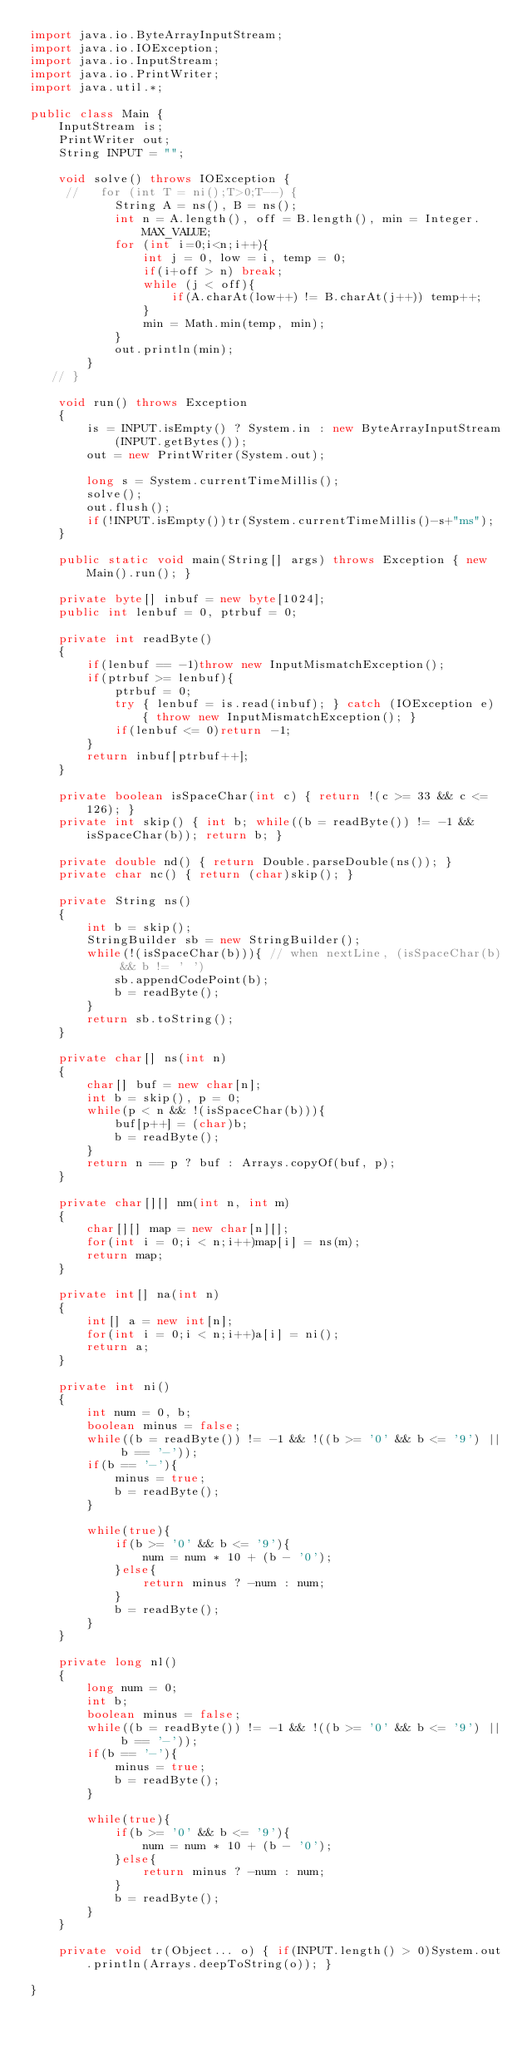Convert code to text. <code><loc_0><loc_0><loc_500><loc_500><_Java_>import java.io.ByteArrayInputStream;
import java.io.IOException;
import java.io.InputStream;
import java.io.PrintWriter;
import java.util.*;

public class Main {
    InputStream is;
    PrintWriter out;
    String INPUT = "";

    void solve() throws IOException {
     //   for (int T = ni();T>0;T--) {
            String A = ns(), B = ns();
            int n = A.length(), off = B.length(), min = Integer.MAX_VALUE;
            for (int i=0;i<n;i++){
                int j = 0, low = i, temp = 0;
                if(i+off > n) break;
                while (j < off){
                    if(A.charAt(low++) != B.charAt(j++)) temp++;
                }
                min = Math.min(temp, min);
            }
            out.println(min);
        }
   // }

    void run() throws Exception
    {
        is = INPUT.isEmpty() ? System.in : new ByteArrayInputStream(INPUT.getBytes());
        out = new PrintWriter(System.out);

        long s = System.currentTimeMillis();
        solve();
        out.flush();
        if(!INPUT.isEmpty())tr(System.currentTimeMillis()-s+"ms");
    }

    public static void main(String[] args) throws Exception { new Main().run(); }

    private byte[] inbuf = new byte[1024];
    public int lenbuf = 0, ptrbuf = 0;

    private int readByte()
    {
        if(lenbuf == -1)throw new InputMismatchException();
        if(ptrbuf >= lenbuf){
            ptrbuf = 0;
            try { lenbuf = is.read(inbuf); } catch (IOException e) { throw new InputMismatchException(); }
            if(lenbuf <= 0)return -1;
        }
        return inbuf[ptrbuf++];
    }

    private boolean isSpaceChar(int c) { return !(c >= 33 && c <= 126); }
    private int skip() { int b; while((b = readByte()) != -1 && isSpaceChar(b)); return b; }

    private double nd() { return Double.parseDouble(ns()); }
    private char nc() { return (char)skip(); }

    private String ns()
    {
        int b = skip();
        StringBuilder sb = new StringBuilder();
        while(!(isSpaceChar(b))){ // when nextLine, (isSpaceChar(b) && b != ' ')
            sb.appendCodePoint(b);
            b = readByte();
        }
        return sb.toString();
    }

    private char[] ns(int n)
    {
        char[] buf = new char[n];
        int b = skip(), p = 0;
        while(p < n && !(isSpaceChar(b))){
            buf[p++] = (char)b;
            b = readByte();
        }
        return n == p ? buf : Arrays.copyOf(buf, p);
    }

    private char[][] nm(int n, int m)
    {
        char[][] map = new char[n][];
        for(int i = 0;i < n;i++)map[i] = ns(m);
        return map;
    }

    private int[] na(int n)
    {
        int[] a = new int[n];
        for(int i = 0;i < n;i++)a[i] = ni();
        return a;
    }

    private int ni()
    {
        int num = 0, b;
        boolean minus = false;
        while((b = readByte()) != -1 && !((b >= '0' && b <= '9') || b == '-'));
        if(b == '-'){
            minus = true;
            b = readByte();
        }

        while(true){
            if(b >= '0' && b <= '9'){
                num = num * 10 + (b - '0');
            }else{
                return minus ? -num : num;
            }
            b = readByte();
        }
    }

    private long nl()
    {
        long num = 0;
        int b;
        boolean minus = false;
        while((b = readByte()) != -1 && !((b >= '0' && b <= '9') || b == '-'));
        if(b == '-'){
            minus = true;
            b = readByte();
        }

        while(true){
            if(b >= '0' && b <= '9'){
                num = num * 10 + (b - '0');
            }else{
                return minus ? -num : num;
            }
            b = readByte();
        }
    }

    private void tr(Object... o) { if(INPUT.length() > 0)System.out.println(Arrays.deepToString(o)); }

}
</code> 